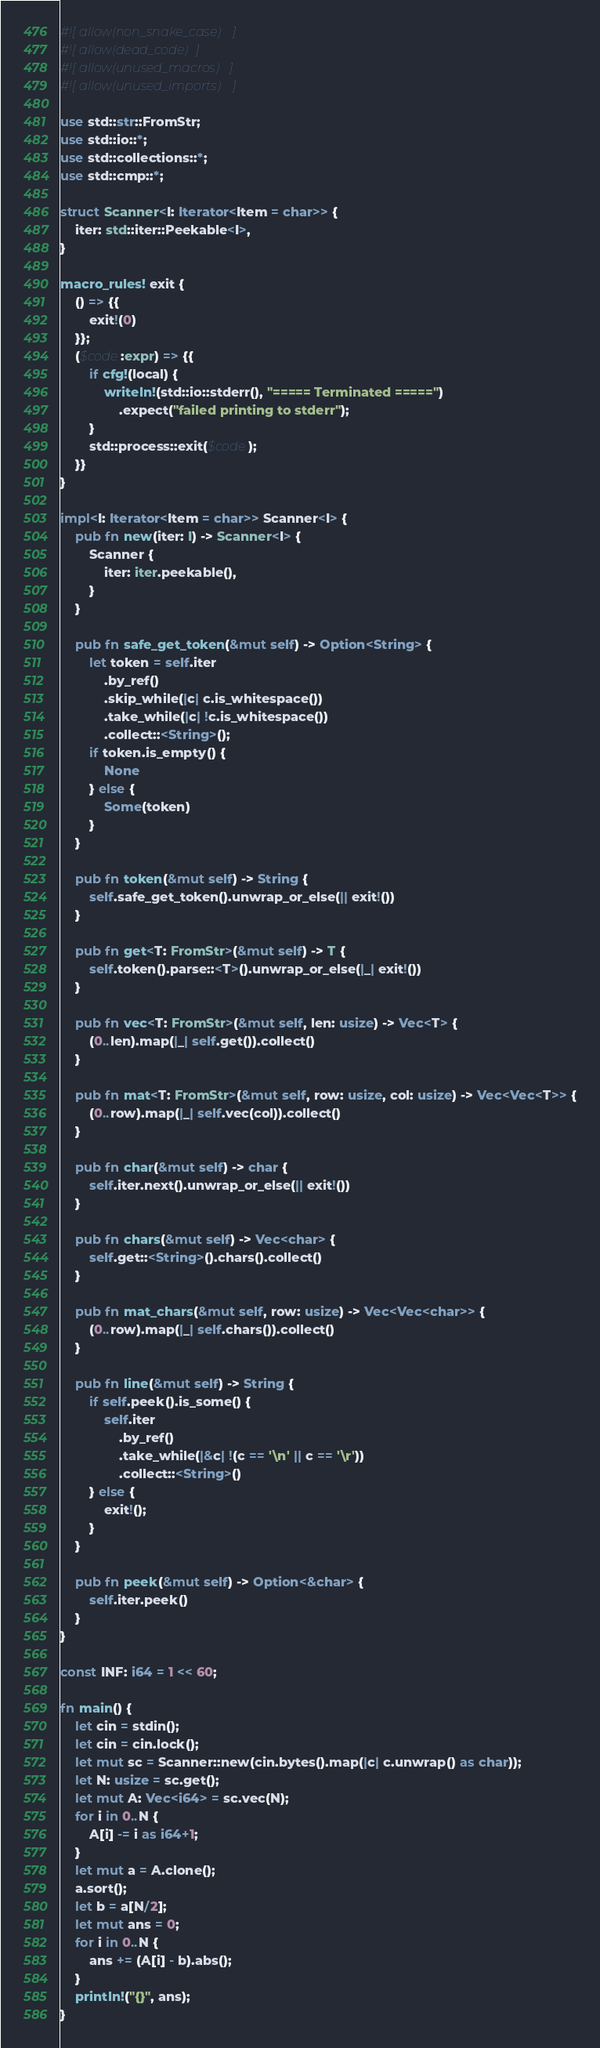<code> <loc_0><loc_0><loc_500><loc_500><_Rust_>#![allow(non_snake_case)]
#![allow(dead_code)]
#![allow(unused_macros)]
#![allow(unused_imports)]

use std::str::FromStr;
use std::io::*;
use std::collections::*;
use std::cmp::*;

struct Scanner<I: Iterator<Item = char>> {
    iter: std::iter::Peekable<I>,
}

macro_rules! exit {
    () => {{
        exit!(0)
    }};
    ($code:expr) => {{
        if cfg!(local) {
            writeln!(std::io::stderr(), "===== Terminated =====")
                .expect("failed printing to stderr");
        }
        std::process::exit($code);
    }}
}

impl<I: Iterator<Item = char>> Scanner<I> {
    pub fn new(iter: I) -> Scanner<I> {
        Scanner {
            iter: iter.peekable(),
        }
    }

    pub fn safe_get_token(&mut self) -> Option<String> {
        let token = self.iter
            .by_ref()
            .skip_while(|c| c.is_whitespace())
            .take_while(|c| !c.is_whitespace())
            .collect::<String>();
        if token.is_empty() {
            None
        } else {
            Some(token)
        }
    }

    pub fn token(&mut self) -> String {
        self.safe_get_token().unwrap_or_else(|| exit!())
    }

    pub fn get<T: FromStr>(&mut self) -> T {
        self.token().parse::<T>().unwrap_or_else(|_| exit!())
    }

    pub fn vec<T: FromStr>(&mut self, len: usize) -> Vec<T> {
        (0..len).map(|_| self.get()).collect()
    }

    pub fn mat<T: FromStr>(&mut self, row: usize, col: usize) -> Vec<Vec<T>> {
        (0..row).map(|_| self.vec(col)).collect()
    }

    pub fn char(&mut self) -> char {
        self.iter.next().unwrap_or_else(|| exit!())
    }

    pub fn chars(&mut self) -> Vec<char> {
        self.get::<String>().chars().collect()
    }

    pub fn mat_chars(&mut self, row: usize) -> Vec<Vec<char>> {
        (0..row).map(|_| self.chars()).collect()
    }

    pub fn line(&mut self) -> String {
        if self.peek().is_some() {
            self.iter
                .by_ref()
                .take_while(|&c| !(c == '\n' || c == '\r'))
                .collect::<String>()
        } else {
            exit!();
        }
    }

    pub fn peek(&mut self) -> Option<&char> {
        self.iter.peek()
    }
}

const INF: i64 = 1 << 60;

fn main() {
    let cin = stdin();
    let cin = cin.lock();
    let mut sc = Scanner::new(cin.bytes().map(|c| c.unwrap() as char));
    let N: usize = sc.get();
    let mut A: Vec<i64> = sc.vec(N);
    for i in 0..N {
        A[i] -= i as i64+1;
    }
    let mut a = A.clone();
    a.sort();
    let b = a[N/2];
    let mut ans = 0;
    for i in 0..N {
        ans += (A[i] - b).abs();
    }
    println!("{}", ans);
}
</code> 